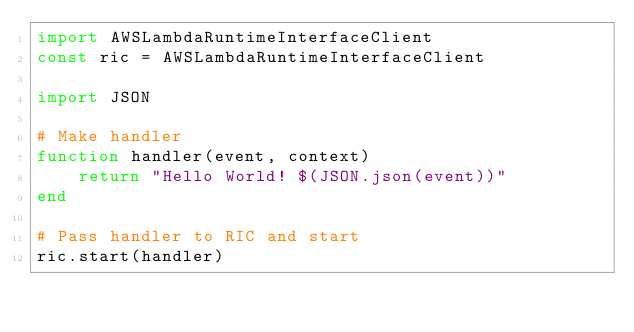Convert code to text. <code><loc_0><loc_0><loc_500><loc_500><_Julia_>import AWSLambdaRuntimeInterfaceClient
const ric = AWSLambdaRuntimeInterfaceClient

import JSON

# Make handler
function handler(event, context)
    return "Hello World! $(JSON.json(event))"
end

# Pass handler to RIC and start
ric.start(handler)
</code> 